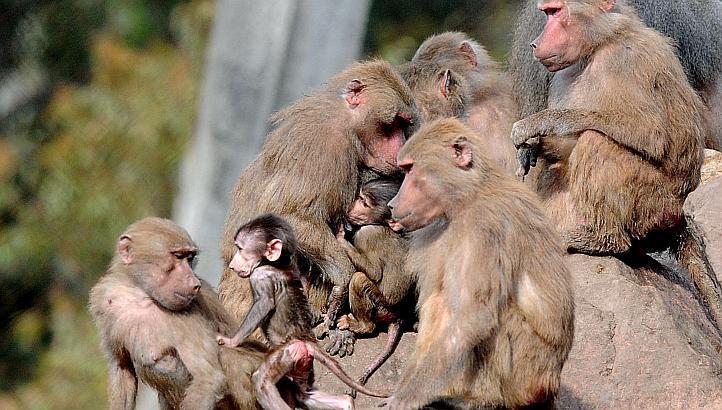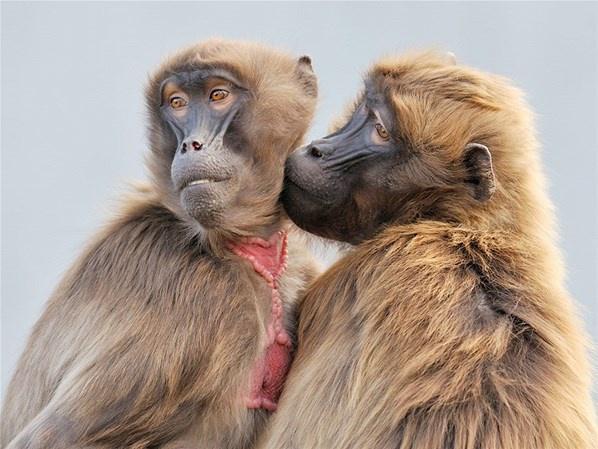The first image is the image on the left, the second image is the image on the right. Analyze the images presented: Is the assertion "Each image contains the face of an ape with teeth showing, and at least one image shows a wide-open mouth." valid? Answer yes or no. No. The first image is the image on the left, the second image is the image on the right. Assess this claim about the two images: "The primate in the image on the left has its mouth wide open.". Correct or not? Answer yes or no. No. 